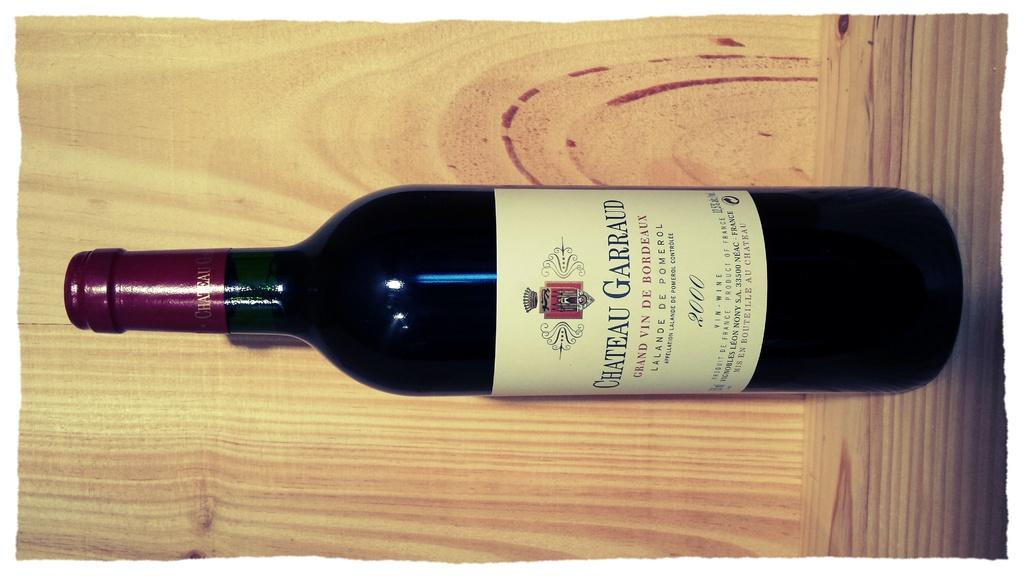<image>
Offer a succinct explanation of the picture presented. A bottle of Chateau Garraud is on a wooden shelf. 